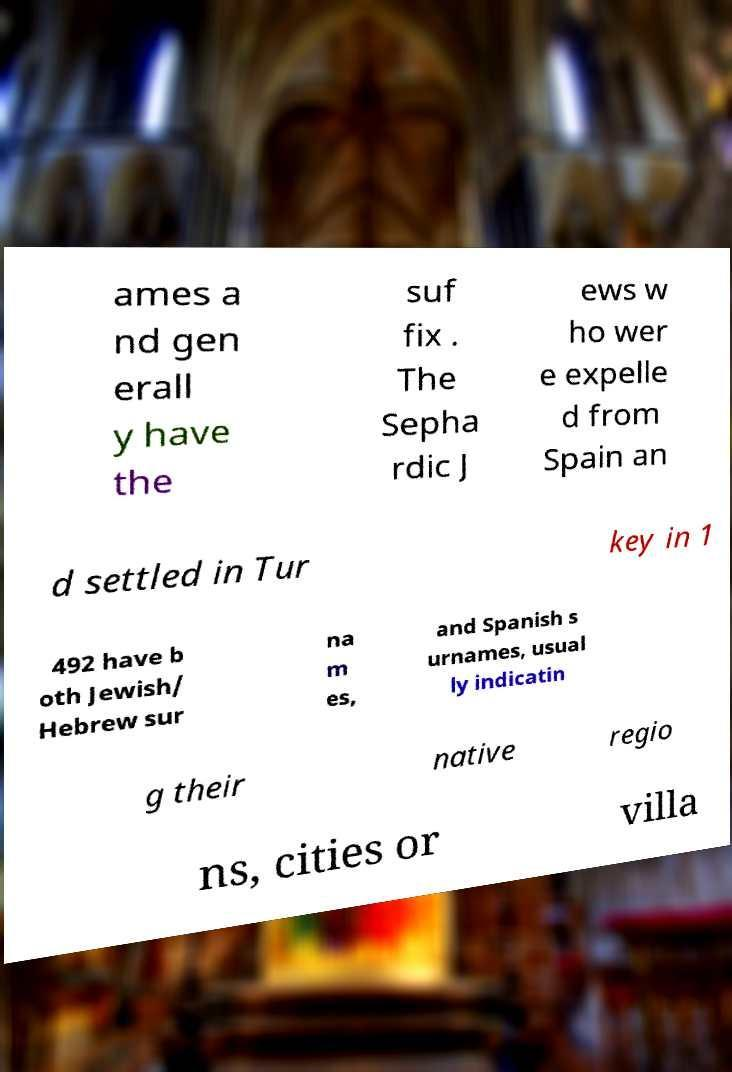What messages or text are displayed in this image? I need them in a readable, typed format. ames a nd gen erall y have the suf fix . The Sepha rdic J ews w ho wer e expelle d from Spain an d settled in Tur key in 1 492 have b oth Jewish/ Hebrew sur na m es, and Spanish s urnames, usual ly indicatin g their native regio ns, cities or villa 